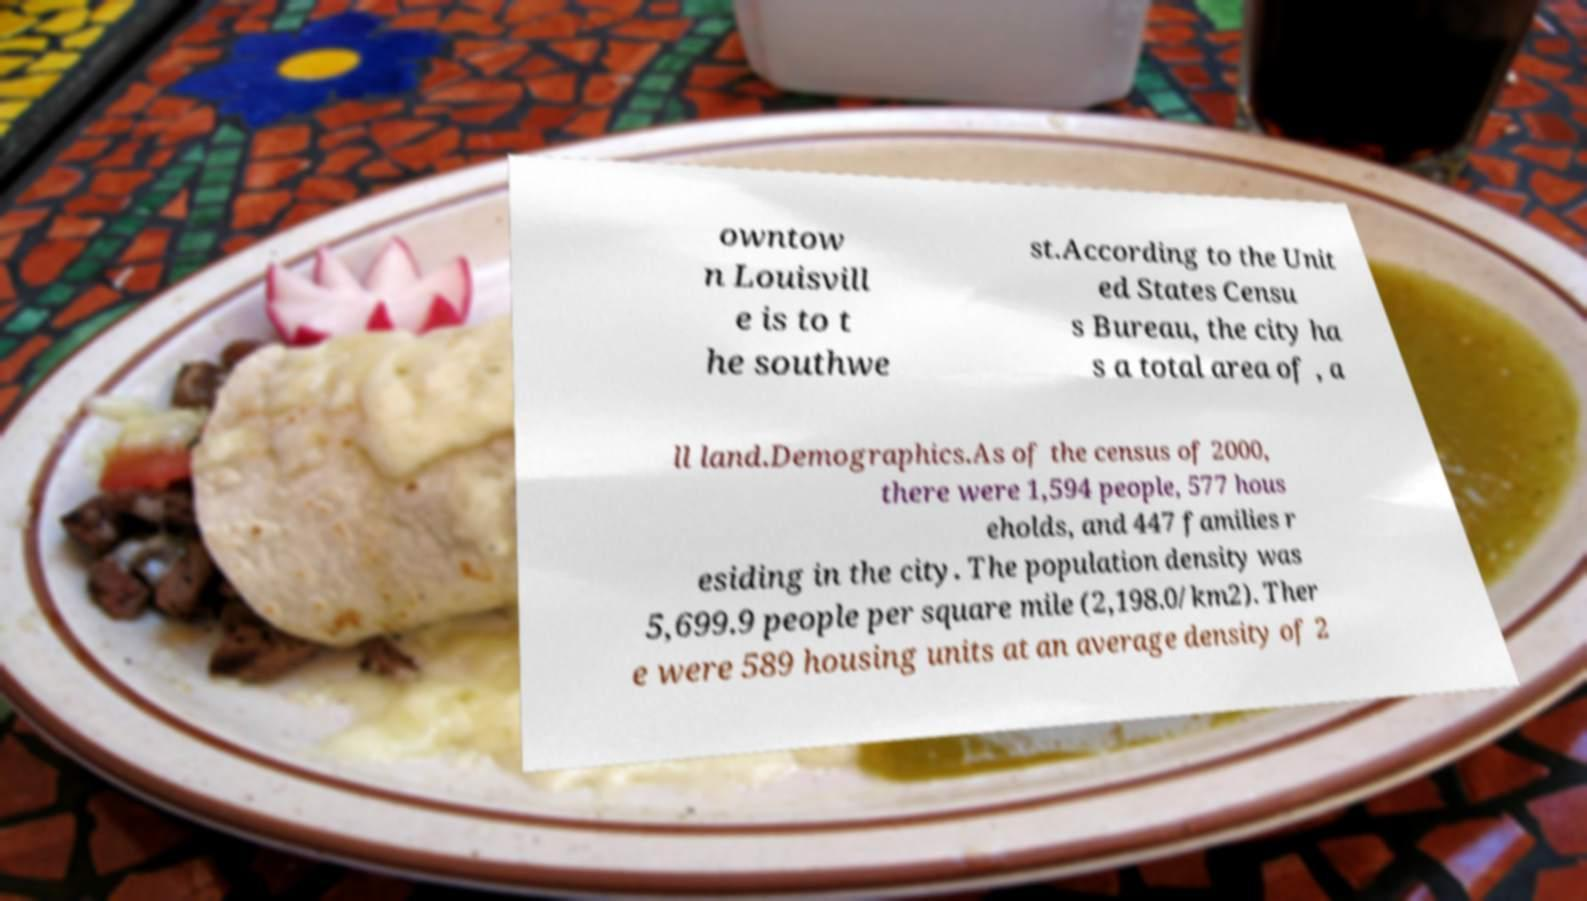Could you extract and type out the text from this image? owntow n Louisvill e is to t he southwe st.According to the Unit ed States Censu s Bureau, the city ha s a total area of , a ll land.Demographics.As of the census of 2000, there were 1,594 people, 577 hous eholds, and 447 families r esiding in the city. The population density was 5,699.9 people per square mile (2,198.0/km2). Ther e were 589 housing units at an average density of 2 